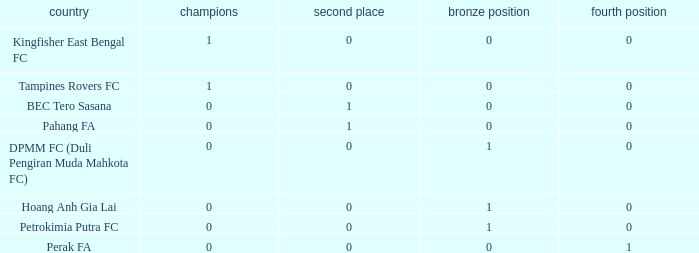Name the average 3rd place with winners of 0, 4th place of 0 and nation of pahang fa 0.0. 